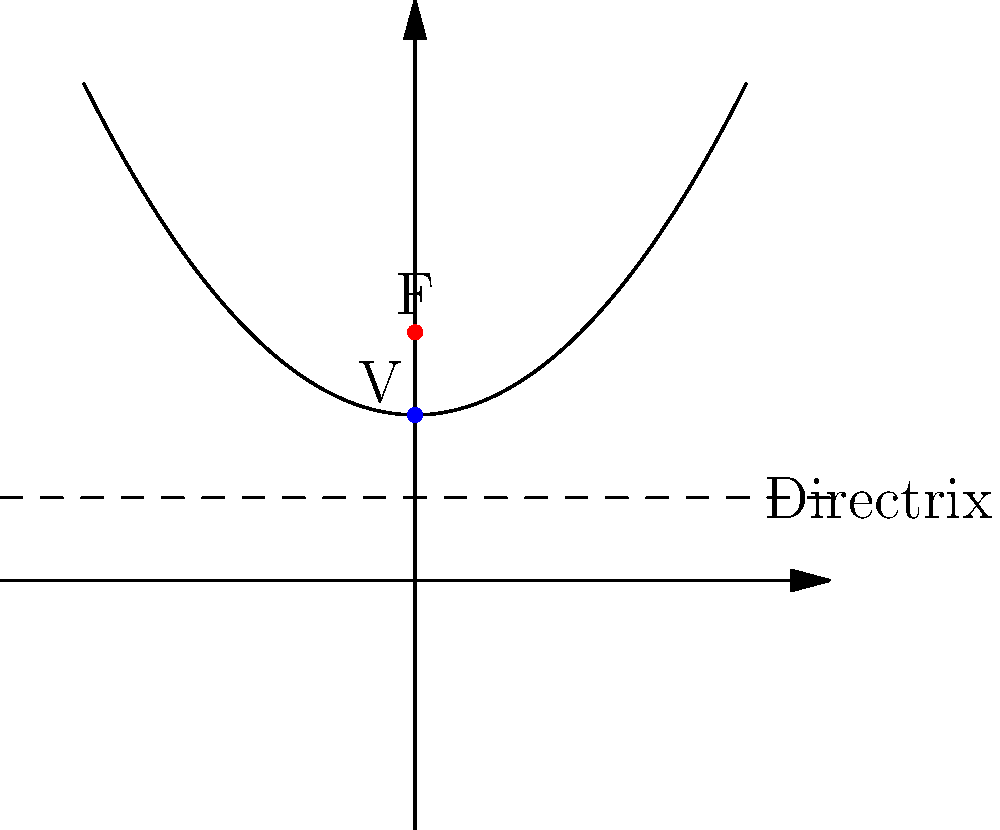Imagine you're designing a sound wave visualizer for your samba radio show. The parabolic shape of the visualizer is represented by the graph above. Given that the focus (F) is at (0, 3) and the directrix is the horizontal line y = 1, determine the equation of this parabola in standard form: $y = a(x - h)^2 + k$, where (h, k) is the vertex of the parabola. Let's approach this step-by-step, relating it to creating the perfect sound wave for samba:

1) First, we need to find the vertex (h, k) of the parabola. In a parabola, the vertex is halfway between the focus and the directrix.

   The y-coordinate of the focus is 3, and the y-coordinate of the directrix is 1.
   So, k = (3 + 1) / 2 = 2

   The x-coordinate of the vertex is the same as the focus, so h = 0.

   Therefore, the vertex V is at (0, 2).

2) Now, we need to find the value of 'a'. We can use the focus-directrix definition of a parabola:
   The distance from any point on the parabola to the focus is equal to the distance from that point to the directrix.

3) We can use the vertex to find 'a'. The distance from the vertex to the focus is:
   3 - 2 = 1

4) The distance from the vertex to the directrix is also:
   2 - 1 = 1

5) For a parabola in the form $y = a(x - h)^2 + k$, the distance from the vertex to the focus is $\frac{1}{4a}$.

   So, $\frac{1}{4a} = 1$
      $\frac{1}{4} = a$
      $a = 0.25$

6) Now we have all the components to write the equation:
   $y = 0.25(x - 0)^2 + 2$

7) Simplifying:
   $y = 0.25x^2 + 2$

This equation represents the perfect parabolic sound wave for your samba visualizer!
Answer: $y = 0.25x^2 + 2$ 